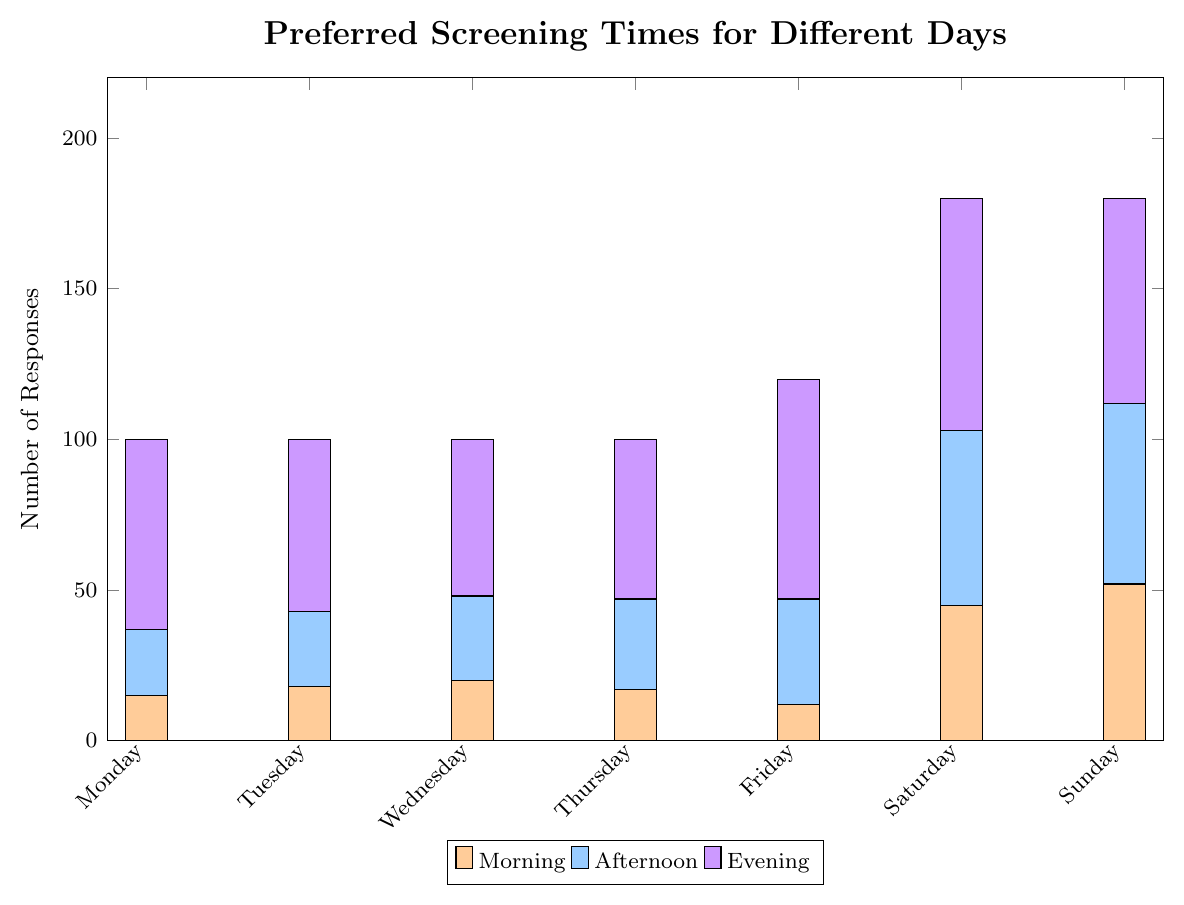What is the most preferred screening time on Friday? Looking at the bar heights on Friday, the evening bar is the highest.
Answer: Evening What is the least preferred screening time on Saturday? Examining the stacked bars for Saturday, the morning bar is the shortest.
Answer: Morning Which day of the week has the highest combined preference for screenings in the afternoon and evening? Sum the afternoon and evening responses for each day: Monday (22+63=85), Tuesday (25+57=82), Wednesday (28+52=80), Thursday (30+53=83), Friday (35+73=108), Saturday (58+77=135), Sunday (60+68=128). Saturday has the highest total.
Answer: Saturday How many more people prefer morning screenings on Sunday compared to Wednesday? The morning preference for Sunday is 52 and for Wednesday is 20. Subtract 20 from 52.
Answer: 32 Between Monday and Thursday, which day has a higher preference for screenings in the afternoon? Compare the heights of the afternoon bars for Monday (22) and Thursday (30). Thursday is higher.
Answer: Thursday By how much does the combined preference for Sunday screenings exceed that of Tuesday? Add the preferences for each time slot on Sunday (52+60+68=180) and for Tuesday (18+25+57=100). Subtract Tuesday's total from Sunday's total.
Answer: 80 What is the total number of responses for screenings on Saturday? Add the morning, afternoon, and evening responses for Saturday. 45+58+77=180.
Answer: 180 Which day has the lowest number of responses for evening screenings? Examine the evening bars and find Friday (73), Thursday (53), Wednesday (52), Tuesday (57), Monday (63). The lowest is Friday.
Answer: Friday What is the difference in the number of preferred evening screenings between Monday and Sunday? Evening preference for Monday is 63 and for Sunday is 68. Subtract 63 from 68.
Answer: 5 Which day of the week has the most uniformly distributed preferences across the morning, afternoon, and evening times? Examine the bar heights for each day and see which day's bars are most equal in height. Saturday's bars (45, 58, 77) are fairly close compared to the other days.
Answer: Saturday 